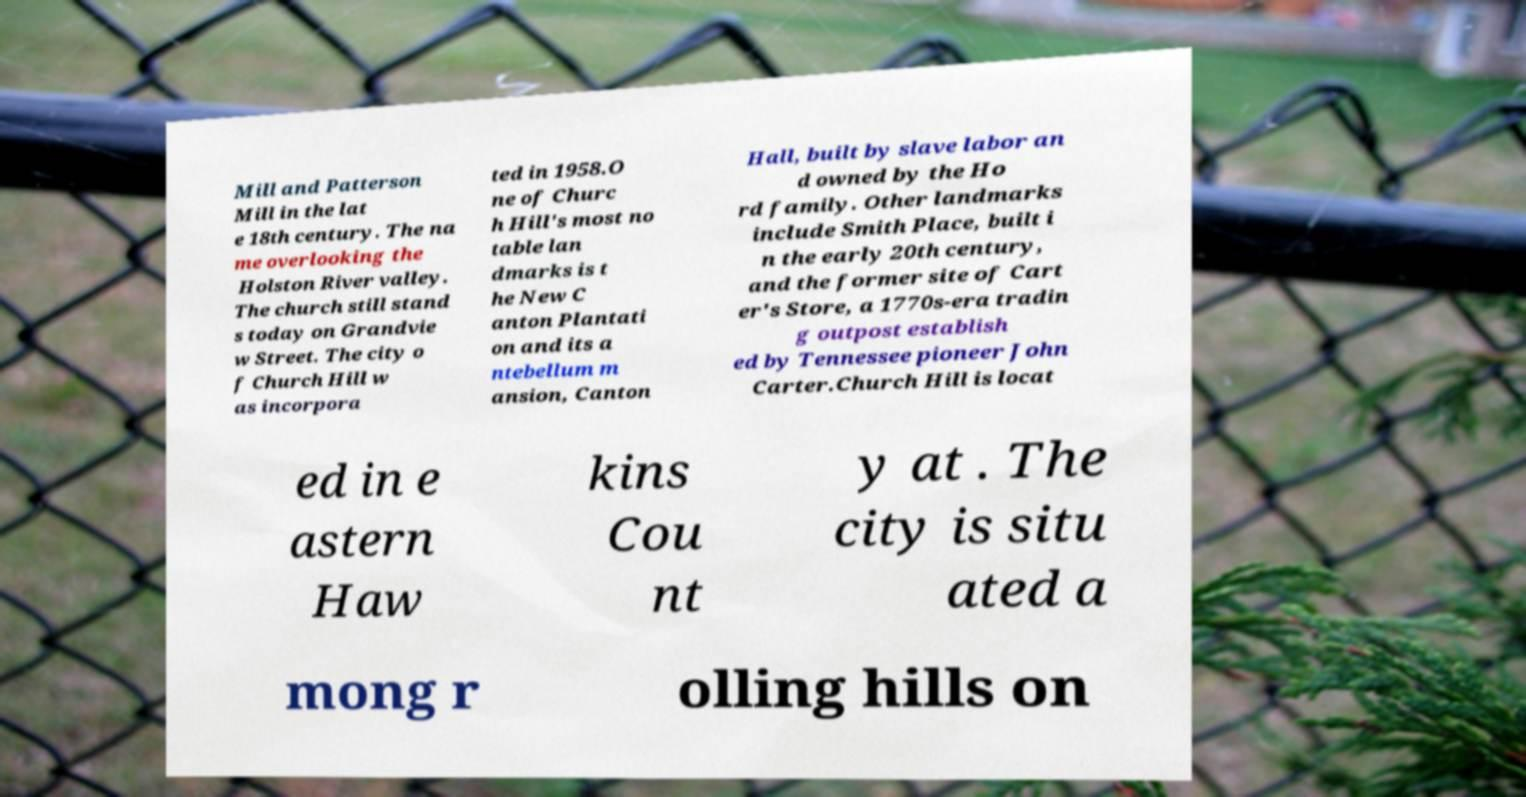For documentation purposes, I need the text within this image transcribed. Could you provide that? Mill and Patterson Mill in the lat e 18th century. The na me overlooking the Holston River valley. The church still stand s today on Grandvie w Street. The city o f Church Hill w as incorpora ted in 1958.O ne of Churc h Hill's most no table lan dmarks is t he New C anton Plantati on and its a ntebellum m ansion, Canton Hall, built by slave labor an d owned by the Ho rd family. Other landmarks include Smith Place, built i n the early 20th century, and the former site of Cart er's Store, a 1770s-era tradin g outpost establish ed by Tennessee pioneer John Carter.Church Hill is locat ed in e astern Haw kins Cou nt y at . The city is situ ated a mong r olling hills on 